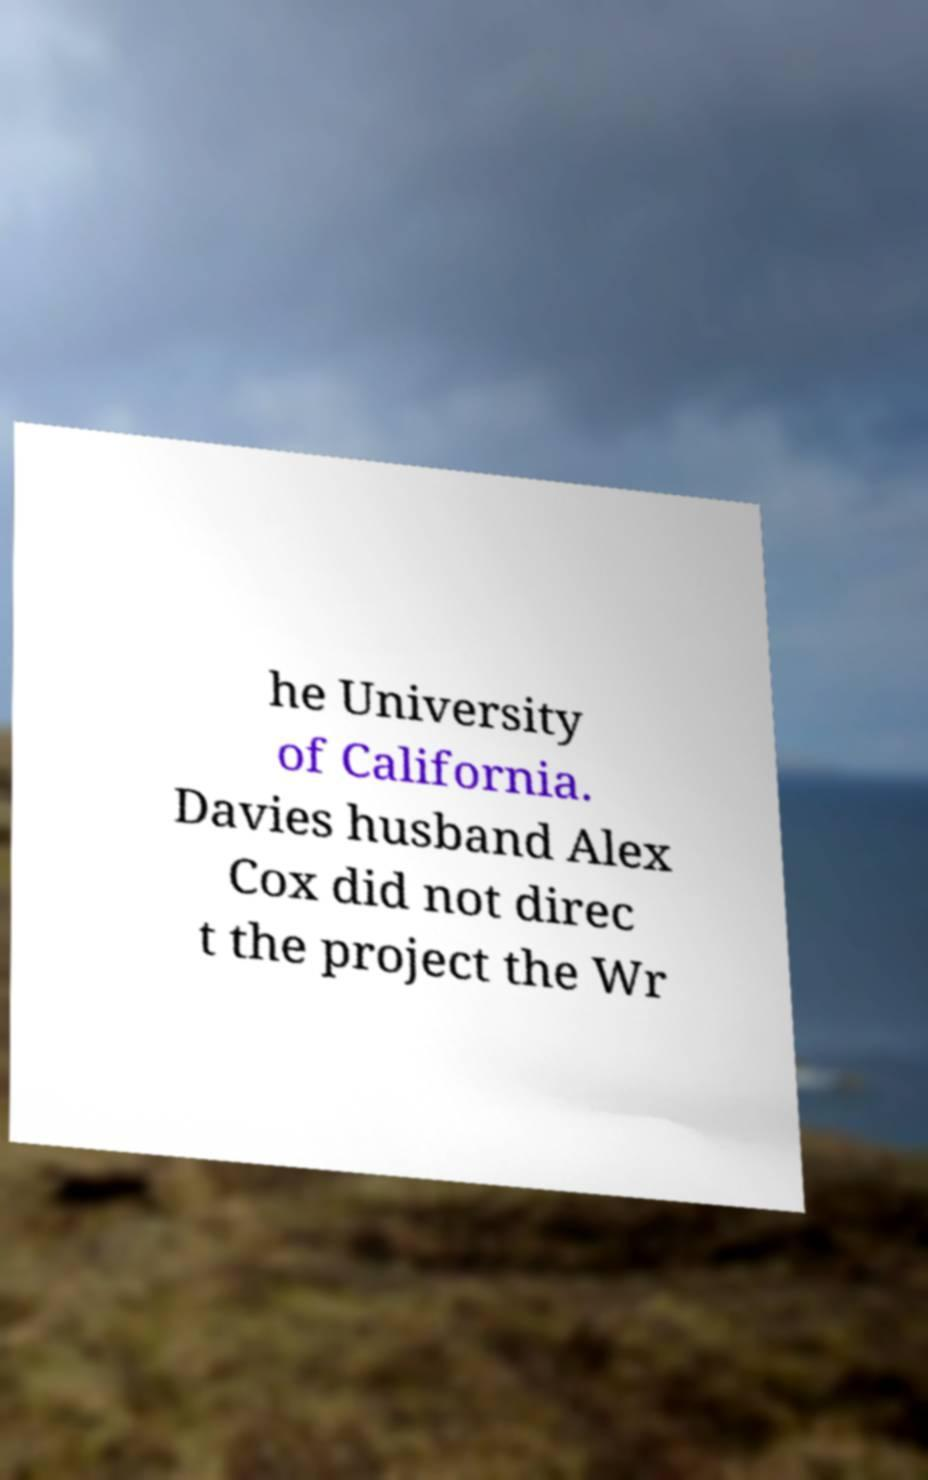Can you accurately transcribe the text from the provided image for me? he University of California. Davies husband Alex Cox did not direc t the project the Wr 